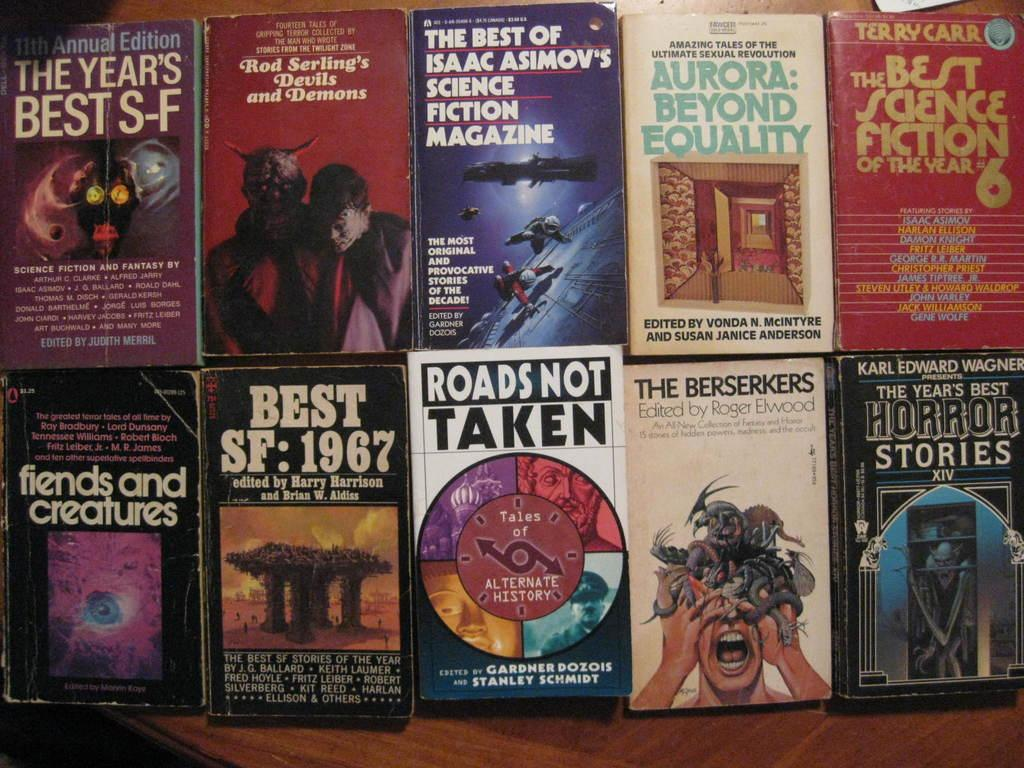<image>
Describe the image concisely. A book called "Roads not Taken"sits next to The Berserkers. 